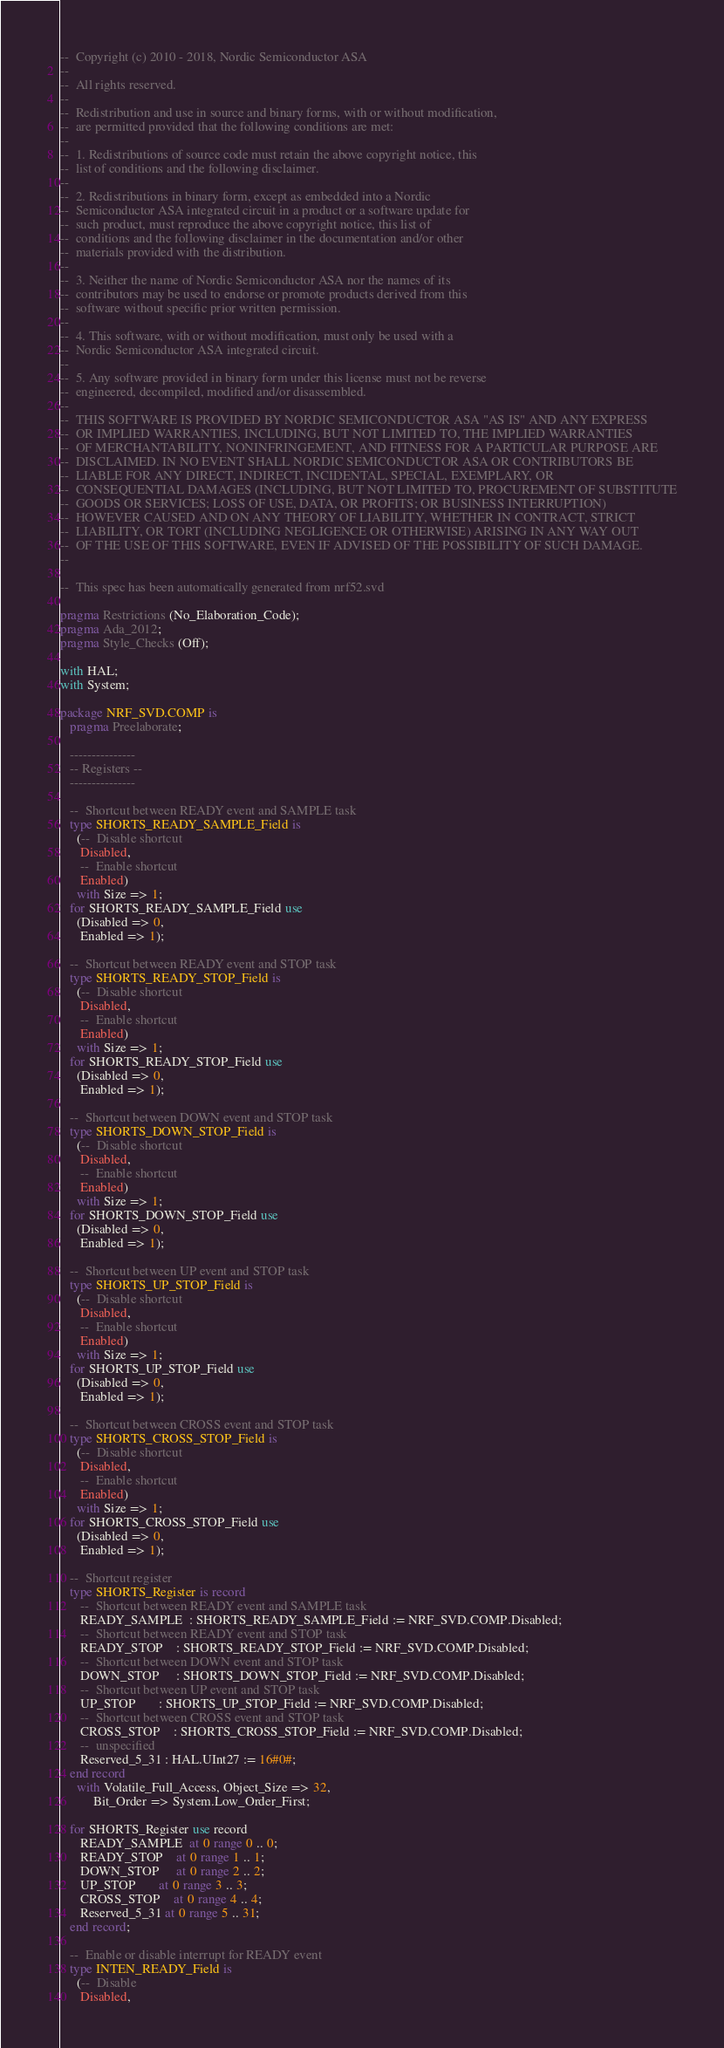Convert code to text. <code><loc_0><loc_0><loc_500><loc_500><_Ada_>--  Copyright (c) 2010 - 2018, Nordic Semiconductor ASA
--
--  All rights reserved.
--
--  Redistribution and use in source and binary forms, with or without modification,
--  are permitted provided that the following conditions are met:
--
--  1. Redistributions of source code must retain the above copyright notice, this
--  list of conditions and the following disclaimer.
--
--  2. Redistributions in binary form, except as embedded into a Nordic
--  Semiconductor ASA integrated circuit in a product or a software update for
--  such product, must reproduce the above copyright notice, this list of
--  conditions and the following disclaimer in the documentation and/or other
--  materials provided with the distribution.
--
--  3. Neither the name of Nordic Semiconductor ASA nor the names of its
--  contributors may be used to endorse or promote products derived from this
--  software without specific prior written permission.
--
--  4. This software, with or without modification, must only be used with a
--  Nordic Semiconductor ASA integrated circuit.
--
--  5. Any software provided in binary form under this license must not be reverse
--  engineered, decompiled, modified and/or disassembled.
--
--  THIS SOFTWARE IS PROVIDED BY NORDIC SEMICONDUCTOR ASA "AS IS" AND ANY EXPRESS
--  OR IMPLIED WARRANTIES, INCLUDING, BUT NOT LIMITED TO, THE IMPLIED WARRANTIES
--  OF MERCHANTABILITY, NONINFRINGEMENT, AND FITNESS FOR A PARTICULAR PURPOSE ARE
--  DISCLAIMED. IN NO EVENT SHALL NORDIC SEMICONDUCTOR ASA OR CONTRIBUTORS BE
--  LIABLE FOR ANY DIRECT, INDIRECT, INCIDENTAL, SPECIAL, EXEMPLARY, OR
--  CONSEQUENTIAL DAMAGES (INCLUDING, BUT NOT LIMITED TO, PROCUREMENT OF SUBSTITUTE
--  GOODS OR SERVICES; LOSS OF USE, DATA, OR PROFITS; OR BUSINESS INTERRUPTION)
--  HOWEVER CAUSED AND ON ANY THEORY OF LIABILITY, WHETHER IN CONTRACT, STRICT
--  LIABILITY, OR TORT (INCLUDING NEGLIGENCE OR OTHERWISE) ARISING IN ANY WAY OUT
--  OF THE USE OF THIS SOFTWARE, EVEN IF ADVISED OF THE POSSIBILITY OF SUCH DAMAGE.
--

--  This spec has been automatically generated from nrf52.svd

pragma Restrictions (No_Elaboration_Code);
pragma Ada_2012;
pragma Style_Checks (Off);

with HAL;
with System;

package NRF_SVD.COMP is
   pragma Preelaborate;

   ---------------
   -- Registers --
   ---------------

   --  Shortcut between READY event and SAMPLE task
   type SHORTS_READY_SAMPLE_Field is
     (--  Disable shortcut
      Disabled,
      --  Enable shortcut
      Enabled)
     with Size => 1;
   for SHORTS_READY_SAMPLE_Field use
     (Disabled => 0,
      Enabled => 1);

   --  Shortcut between READY event and STOP task
   type SHORTS_READY_STOP_Field is
     (--  Disable shortcut
      Disabled,
      --  Enable shortcut
      Enabled)
     with Size => 1;
   for SHORTS_READY_STOP_Field use
     (Disabled => 0,
      Enabled => 1);

   --  Shortcut between DOWN event and STOP task
   type SHORTS_DOWN_STOP_Field is
     (--  Disable shortcut
      Disabled,
      --  Enable shortcut
      Enabled)
     with Size => 1;
   for SHORTS_DOWN_STOP_Field use
     (Disabled => 0,
      Enabled => 1);

   --  Shortcut between UP event and STOP task
   type SHORTS_UP_STOP_Field is
     (--  Disable shortcut
      Disabled,
      --  Enable shortcut
      Enabled)
     with Size => 1;
   for SHORTS_UP_STOP_Field use
     (Disabled => 0,
      Enabled => 1);

   --  Shortcut between CROSS event and STOP task
   type SHORTS_CROSS_STOP_Field is
     (--  Disable shortcut
      Disabled,
      --  Enable shortcut
      Enabled)
     with Size => 1;
   for SHORTS_CROSS_STOP_Field use
     (Disabled => 0,
      Enabled => 1);

   --  Shortcut register
   type SHORTS_Register is record
      --  Shortcut between READY event and SAMPLE task
      READY_SAMPLE  : SHORTS_READY_SAMPLE_Field := NRF_SVD.COMP.Disabled;
      --  Shortcut between READY event and STOP task
      READY_STOP    : SHORTS_READY_STOP_Field := NRF_SVD.COMP.Disabled;
      --  Shortcut between DOWN event and STOP task
      DOWN_STOP     : SHORTS_DOWN_STOP_Field := NRF_SVD.COMP.Disabled;
      --  Shortcut between UP event and STOP task
      UP_STOP       : SHORTS_UP_STOP_Field := NRF_SVD.COMP.Disabled;
      --  Shortcut between CROSS event and STOP task
      CROSS_STOP    : SHORTS_CROSS_STOP_Field := NRF_SVD.COMP.Disabled;
      --  unspecified
      Reserved_5_31 : HAL.UInt27 := 16#0#;
   end record
     with Volatile_Full_Access, Object_Size => 32,
          Bit_Order => System.Low_Order_First;

   for SHORTS_Register use record
      READY_SAMPLE  at 0 range 0 .. 0;
      READY_STOP    at 0 range 1 .. 1;
      DOWN_STOP     at 0 range 2 .. 2;
      UP_STOP       at 0 range 3 .. 3;
      CROSS_STOP    at 0 range 4 .. 4;
      Reserved_5_31 at 0 range 5 .. 31;
   end record;

   --  Enable or disable interrupt for READY event
   type INTEN_READY_Field is
     (--  Disable
      Disabled,</code> 